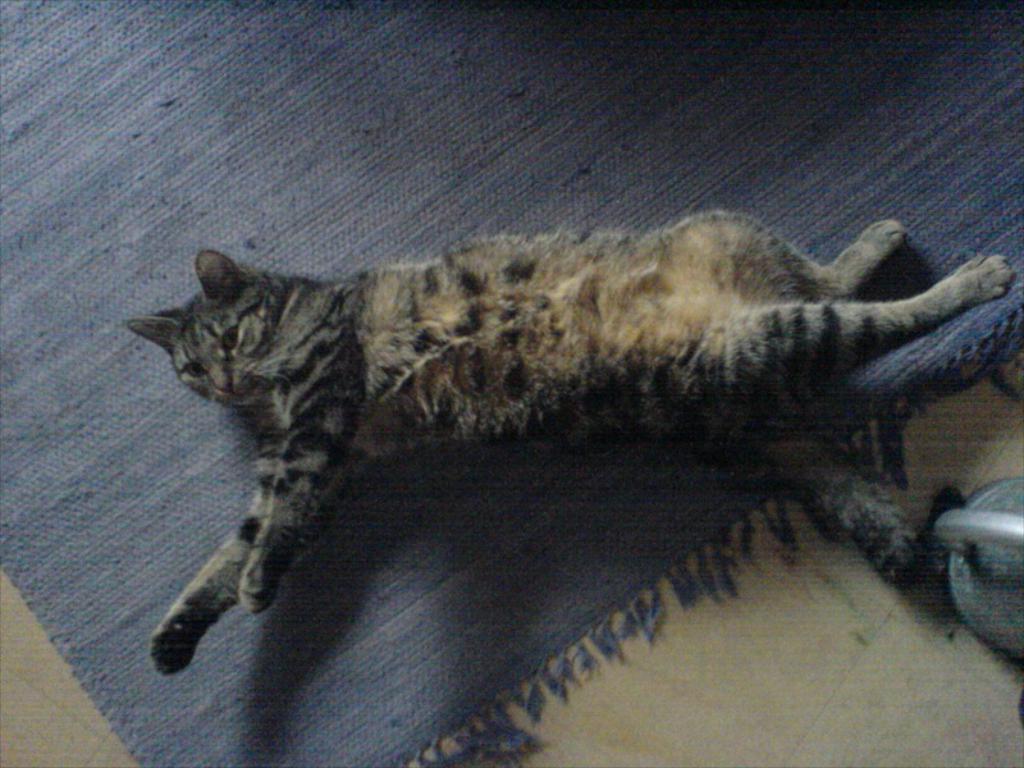How would you summarize this image in a sentence or two? In this picture, we see a cat is lying on the carpet, which is blue in color. At the bottom, we see the floor. On the right side, we see a kettle. 